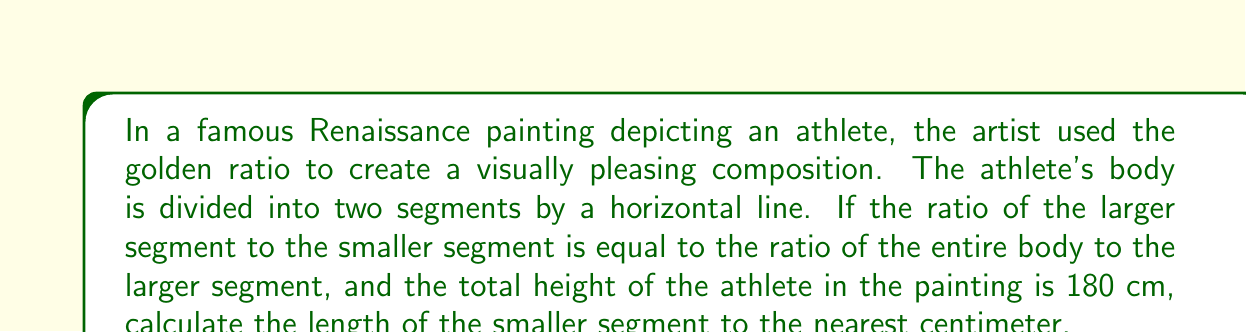Could you help me with this problem? Let's approach this step-by-step:

1) The golden ratio, often denoted by $\phi$ (phi), is defined as:

   $$\phi = \frac{a+b}{a} = \frac{a}{b}$$

   where $a$ is the larger segment and $b$ is the smaller segment.

2) We know that the total height of the athlete is 180 cm. Let's denote this as $h$. So:

   $$h = a + b = 180$$

3) According to the golden ratio:

   $$\frac{a}{b} = \frac{h}{a} = \frac{180}{a}$$

4) This gives us the equation:

   $$\frac{a}{b} = \frac{180}{a}$$

5) Cross multiplying:

   $$a^2 = 180b$$

6) We can substitute $b = 180 - a$ (from step 2):

   $$a^2 = 180(180 - a)$$

7) Expanding:

   $$a^2 = 32400 - 180a$$

8) Rearranging:

   $$a^2 + 180a - 32400 = 0$$

9) This is a quadratic equation. We can solve it using the quadratic formula:

   $$a = \frac{-b \pm \sqrt{b^2 - 4ac}}{2a}$$

   where $a = 1$, $b = 180$, and $c = -32400$

10) Plugging in these values:

    $$a = \frac{-180 \pm \sqrt{180^2 - 4(1)(-32400)}}{2(1)}$$

11) Simplifying:

    $$a = \frac{-180 \pm \sqrt{32400 + 129600}}{2} = \frac{-180 \pm \sqrt{162000}}{2}$$

12) Calculating:

    $$a \approx 111.246$$

13) Since $a + b = 180$, we can find $b$:

    $$b = 180 - 111.246 \approx 68.754$$

14) Rounding to the nearest centimeter:

    $$b \approx 69 \text{ cm}$$
Answer: $69 \text{ cm}$ 